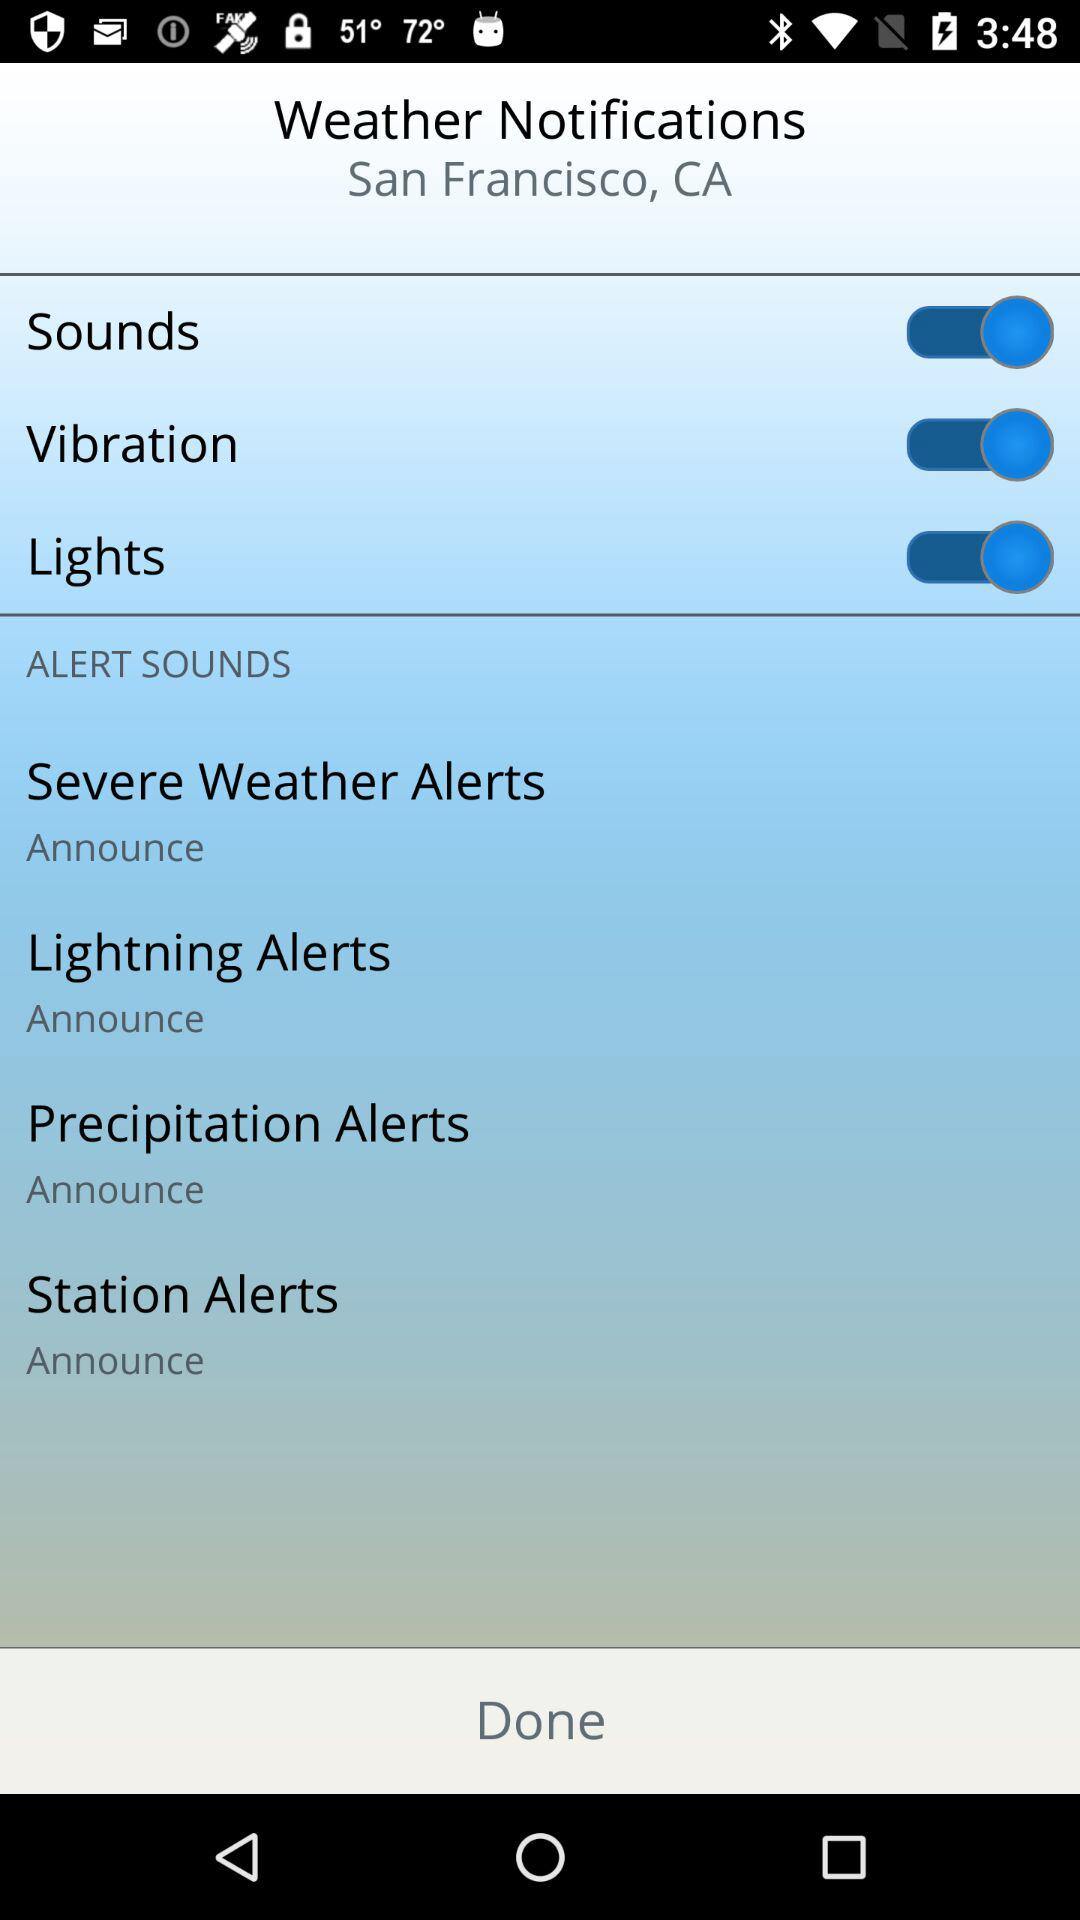How many options are there to customize alert sounds?
Answer the question using a single word or phrase. 4 